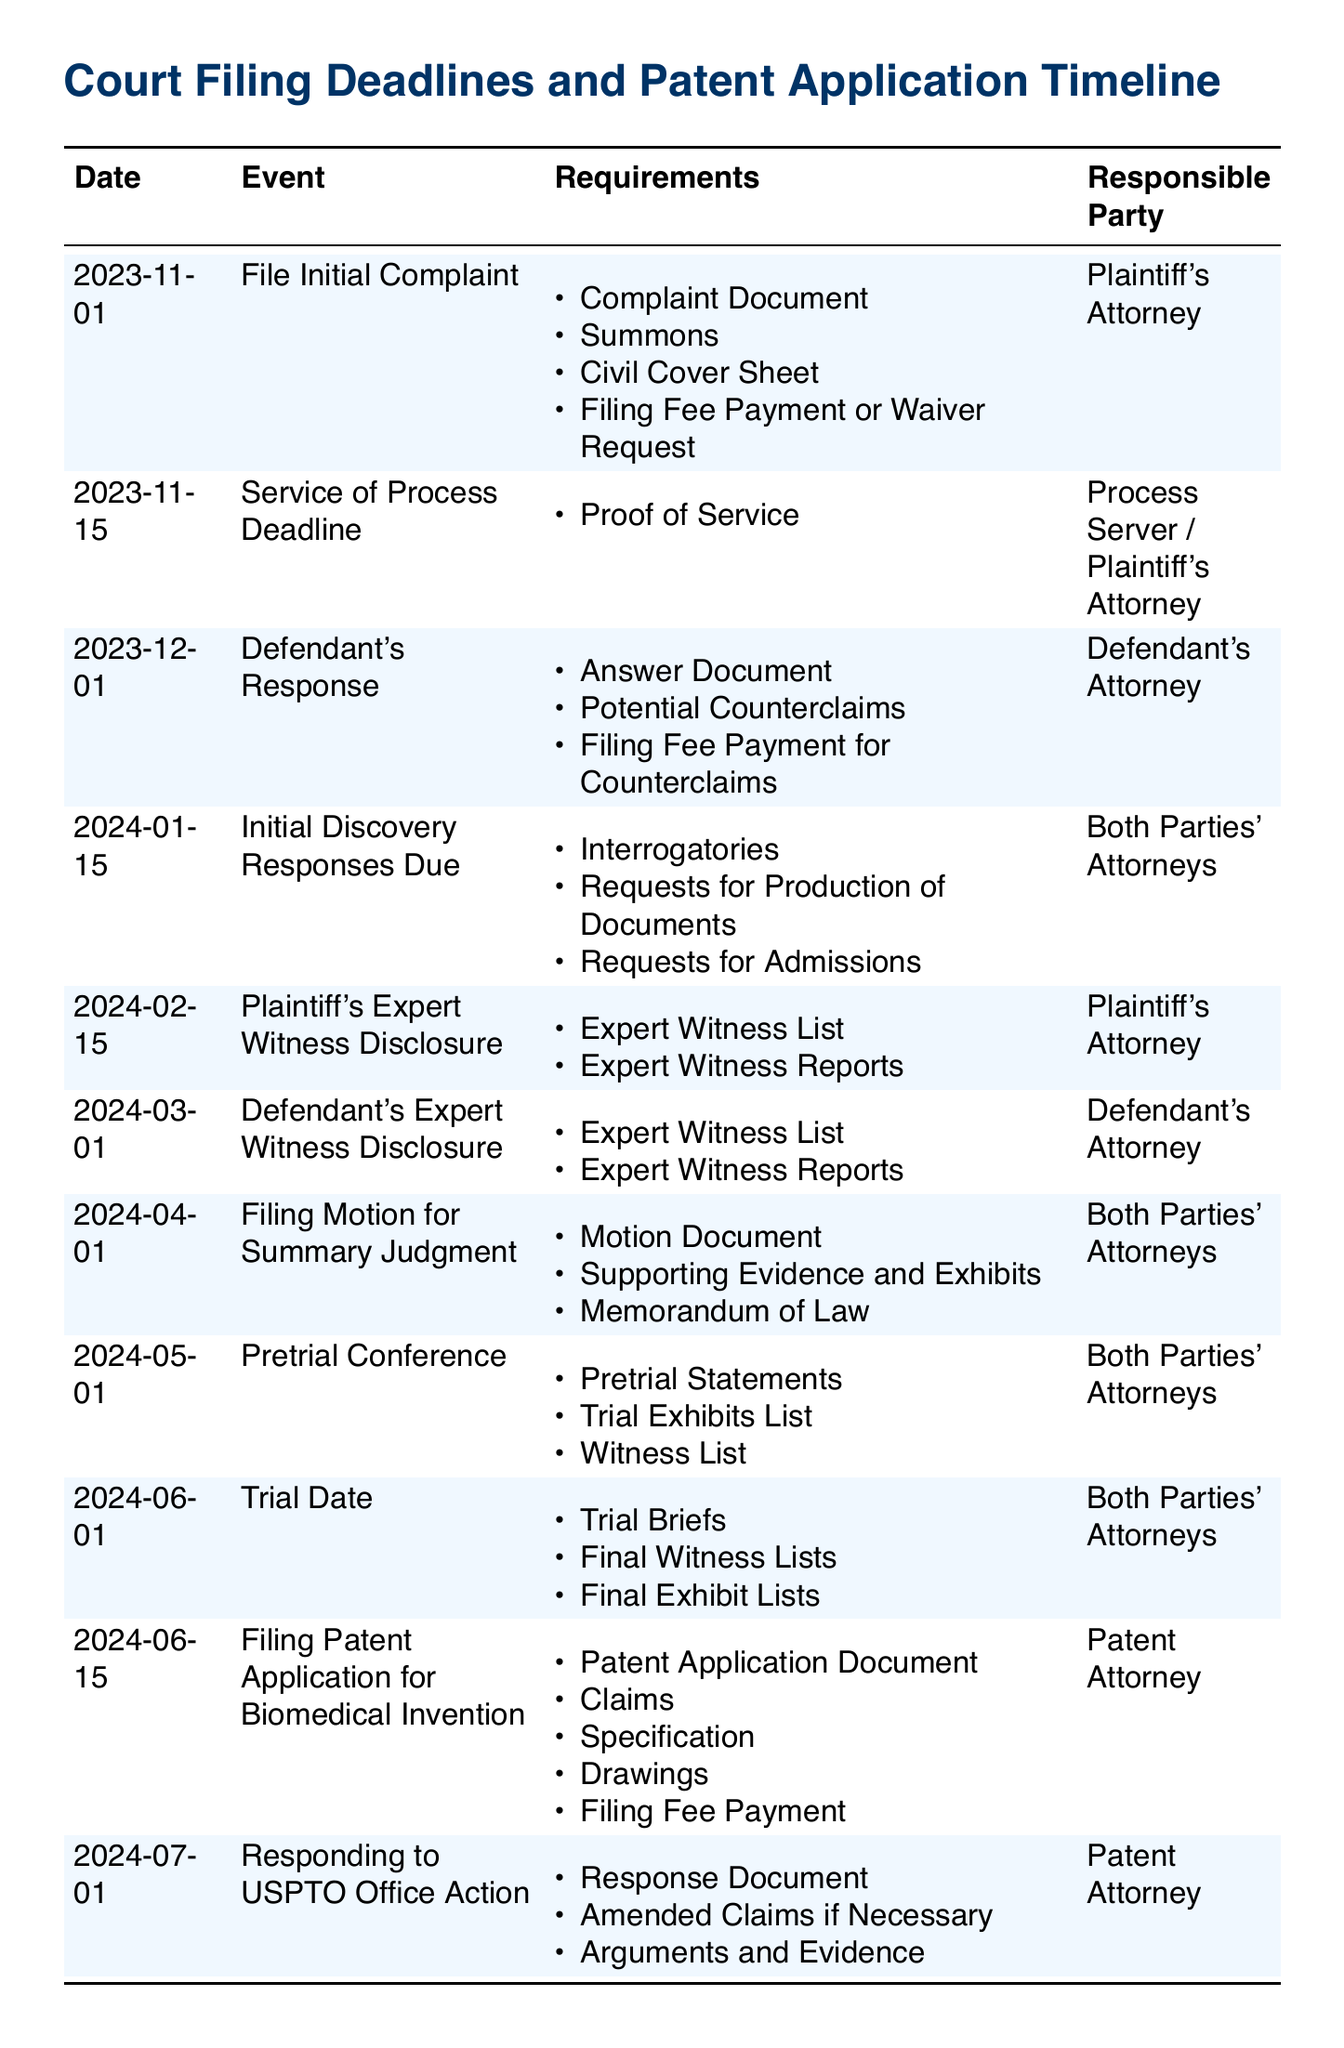What is the filing date for the initial complaint? The document states the filing date for the initial complaint is November 1, 2023.
Answer: November 1, 2023 Who is responsible for the service of process? The responsible party for the service of process is the Process Server or Plaintiff's Attorney.
Answer: Process Server / Plaintiff's Attorney What document is required for filing a patent application? The requirements for filing a patent application include the Patent Application Document, Claims, Specification, Drawings, and Filing Fee Payment.
Answer: Patent Application Document When are initial discovery responses due? The initial discovery responses are due on January 15, 2024, as indicated in the document.
Answer: January 15, 2024 What must be included in the pretrial conference? The pretrial conference requires Pretrial Statements, Trial Exhibits List, and Witness List.
Answer: Pretrial Statements, Trial Exhibits List, Witness List What is the deadline to respond to a USPTO Office Action? According to the document, the deadline to respond to a USPTO Office Action is July 1, 2024.
Answer: July 1, 2024 How many days do both parties have to disclose expert witnesses? The document shows that both parties must disclose expert witnesses by February 15, 2024, and March 1, 2024, respectively, giving a total of 14 days.
Answer: 14 days What is the trial date? The trial date is scheduled for June 1, 2024, as per the listed information.
Answer: June 1, 2024 What type of document is the initial response from the defendant? The initial response from the defendant must be an Answer Document, according to the requirements listed.
Answer: Answer Document 